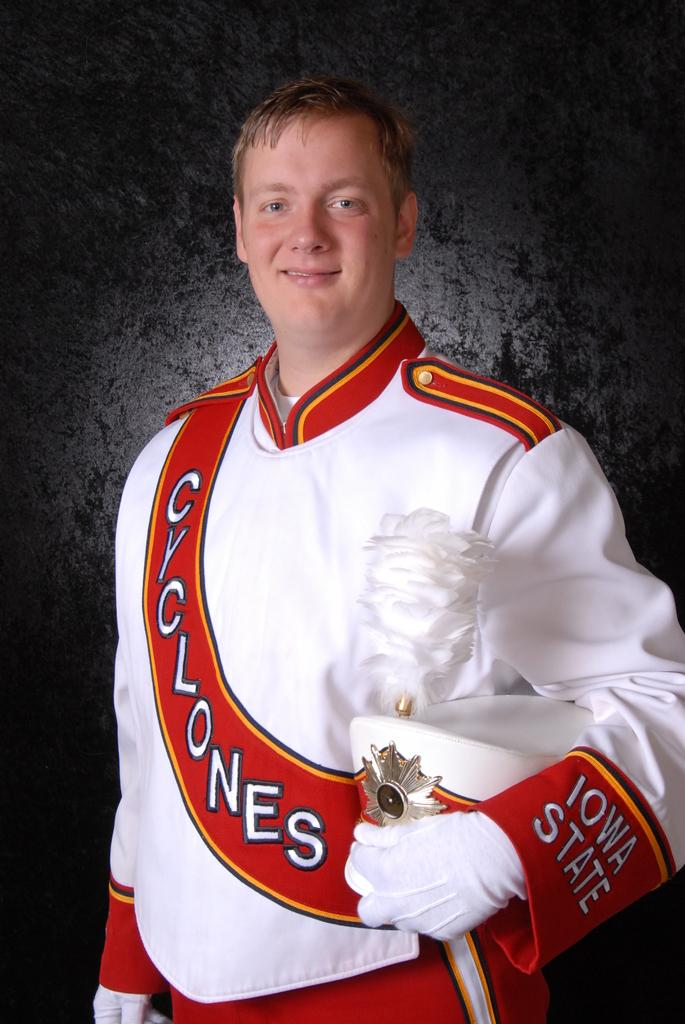<image>
Give a short and clear explanation of the subsequent image. a man wearing a cyclones outfit and holding a hat 